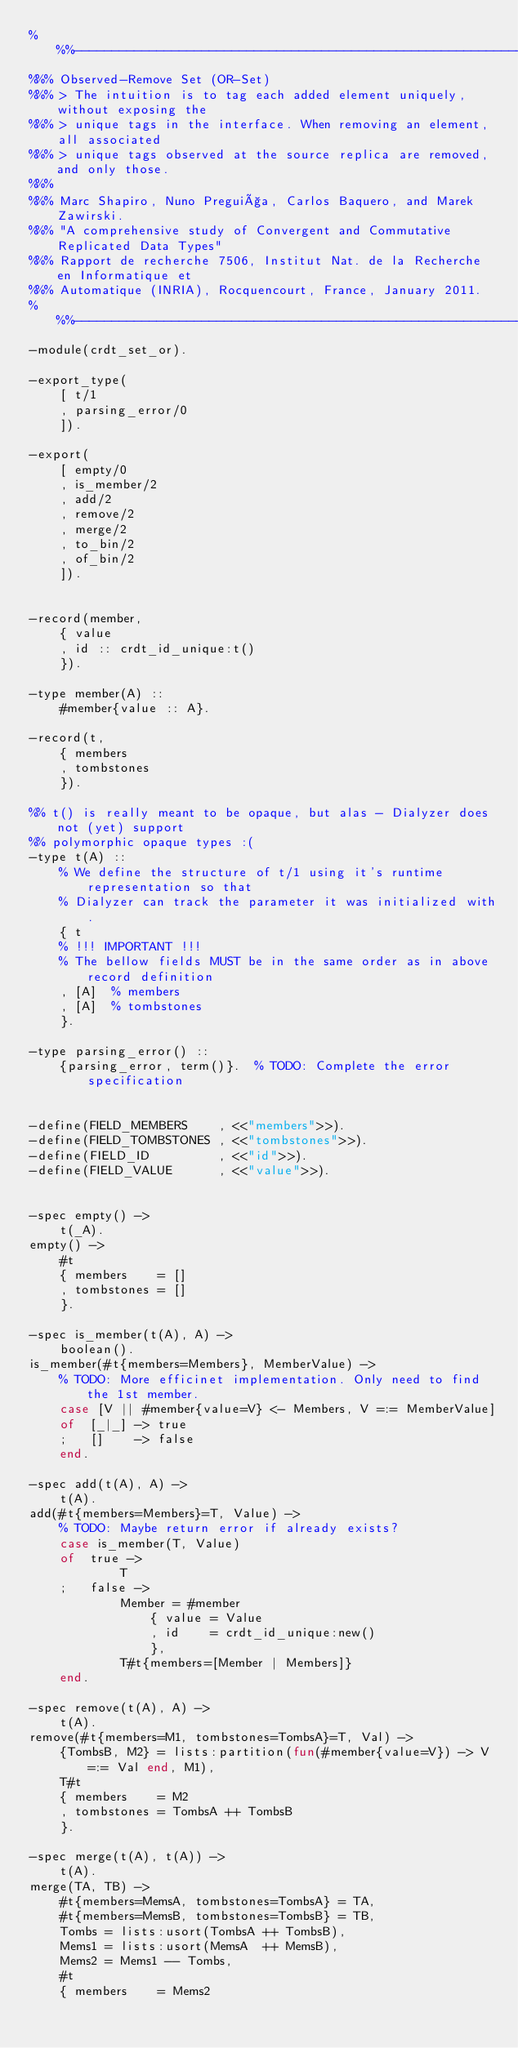<code> <loc_0><loc_0><loc_500><loc_500><_Erlang_>%%%----------------------------------------------------------------------------
%%% Observed-Remove Set (OR-Set)
%%% > The intuition is to tag each added element uniquely, without exposing the
%%% > unique tags in the interface. When removing an element, all associated
%%% > unique tags observed at the source replica are removed, and only those.
%%%
%%% Marc Shapiro, Nuno Preguiça, Carlos Baquero, and Marek Zawirski.
%%% "A comprehensive study of Convergent and Commutative Replicated Data Types"
%%% Rapport de recherche 7506, Institut Nat. de la Recherche en Informatique et
%%% Automatique (INRIA), Rocquencourt, France, January 2011.
%%%----------------------------------------------------------------------------
-module(crdt_set_or).

-export_type(
    [ t/1
    , parsing_error/0
    ]).

-export(
    [ empty/0
    , is_member/2
    , add/2
    , remove/2
    , merge/2
    , to_bin/2
    , of_bin/2
    ]).


-record(member,
    { value
    , id :: crdt_id_unique:t()
    }).

-type member(A) ::
    #member{value :: A}.

-record(t,
    { members
    , tombstones
    }).

%% t() is really meant to be opaque, but alas - Dialyzer does not (yet) support
%% polymorphic opaque types :(
-type t(A) ::
    % We define the structure of t/1 using it's runtime representation so that
    % Dialyzer can track the parameter it was initialized with.
    { t
    % !!! IMPORTANT !!!
    % The bellow fields MUST be in the same order as in above record definition
    , [A]  % members
    , [A]  % tombstones
    }.

-type parsing_error() ::
    {parsing_error, term()}.  % TODO: Complete the error specification


-define(FIELD_MEMBERS    , <<"members">>).
-define(FIELD_TOMBSTONES , <<"tombstones">>).
-define(FIELD_ID         , <<"id">>).
-define(FIELD_VALUE      , <<"value">>).


-spec empty() ->
    t(_A).
empty() ->
    #t
    { members    = []
    , tombstones = []
    }.

-spec is_member(t(A), A) ->
    boolean().
is_member(#t{members=Members}, MemberValue) ->
    % TODO: More efficinet implementation. Only need to find the 1st member.
    case [V || #member{value=V} <- Members, V =:= MemberValue]
    of  [_|_] -> true
    ;   []    -> false
    end.

-spec add(t(A), A) ->
    t(A).
add(#t{members=Members}=T, Value) ->
    % TODO: Maybe return error if already exists?
    case is_member(T, Value)
    of  true ->
            T
    ;   false ->
            Member = #member
                { value = Value
                , id    = crdt_id_unique:new()
                },
            T#t{members=[Member | Members]}
    end.

-spec remove(t(A), A) ->
    t(A).
remove(#t{members=M1, tombstones=TombsA}=T, Val) ->
    {TombsB, M2} = lists:partition(fun(#member{value=V}) -> V =:= Val end, M1),
    T#t
    { members    = M2
    , tombstones = TombsA ++ TombsB
    }.

-spec merge(t(A), t(A)) ->
    t(A).
merge(TA, TB) ->
    #t{members=MemsA, tombstones=TombsA} = TA,
    #t{members=MemsB, tombstones=TombsB} = TB,
    Tombs = lists:usort(TombsA ++ TombsB),
    Mems1 = lists:usort(MemsA  ++ MemsB),
    Mems2 = Mems1 -- Tombs,
    #t
    { members    = Mems2</code> 